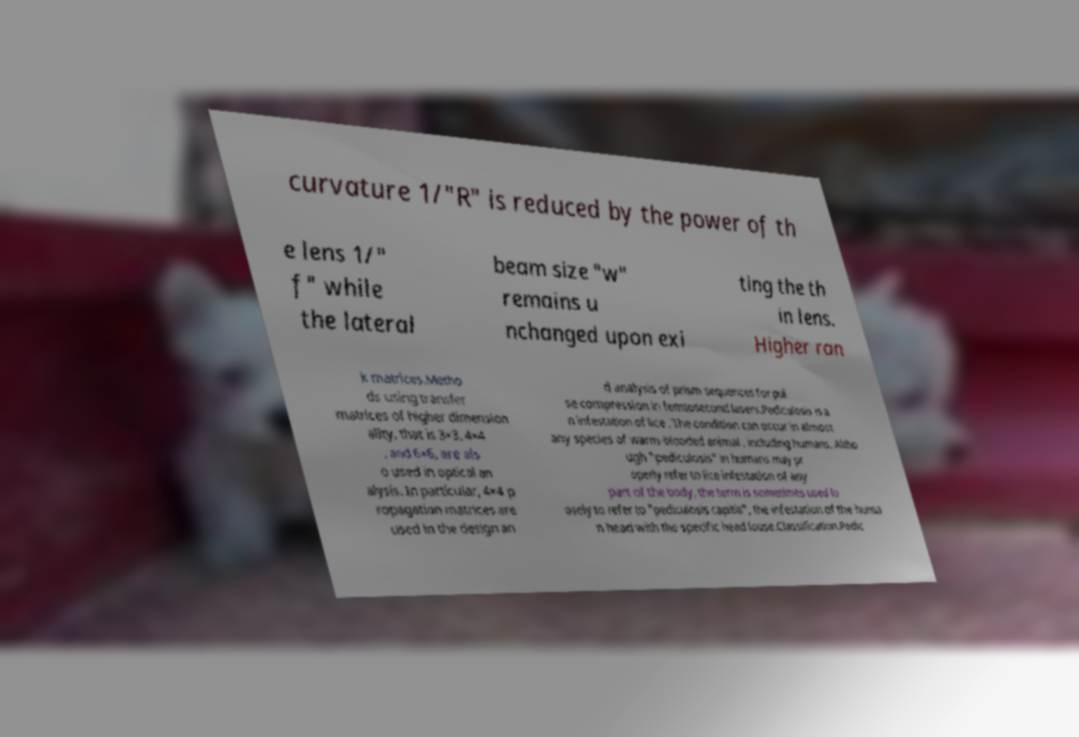For documentation purposes, I need the text within this image transcribed. Could you provide that? curvature 1/"R" is reduced by the power of th e lens 1/" f" while the lateral beam size "w" remains u nchanged upon exi ting the th in lens. Higher ran k matrices.Metho ds using transfer matrices of higher dimension ality, that is 3×3, 4×4 , and 6×6, are als o used in optical an alysis. In particular, 4×4 p ropagation matrices are used in the design an d analysis of prism sequences for pul se compression in femtosecond lasers.Pediculosis is a n infestation of lice . The condition can occur in almost any species of warm-blooded animal , including humans. Altho ugh "pediculosis" in humans may pr operly refer to lice infestation of any part of the body, the term is sometimes used lo osely to refer to "pediculosis capitis", the infestation of the huma n head with the specific head louse.Classification.Pedic 